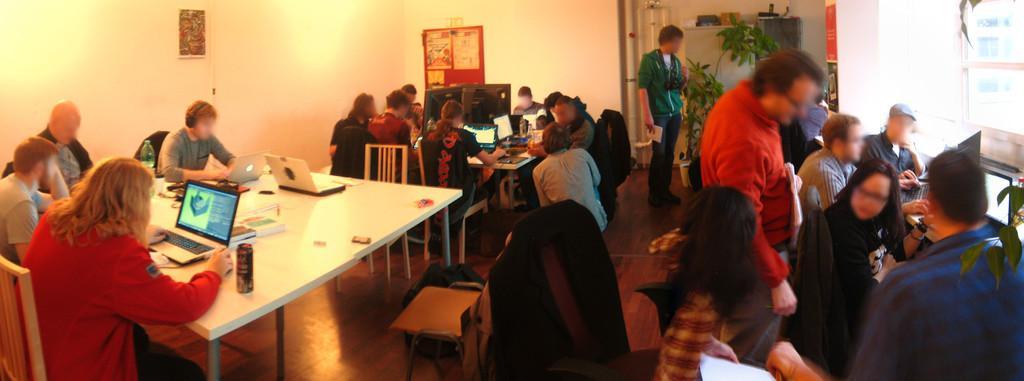In one or two sentences, can you explain what this image depicts? In this picture we can see two persons are standing and some people are sitting on chairs in front of tables, there are laptops, books, a bottle and a tin placed on this table, in the background there is a wall, we can see charts pasted to the wall, on the right side there are plants. 